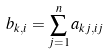Convert formula to latex. <formula><loc_0><loc_0><loc_500><loc_500>b _ { k , i } = \sum _ { j = 1 } ^ { n } a _ { k j , i j }</formula> 